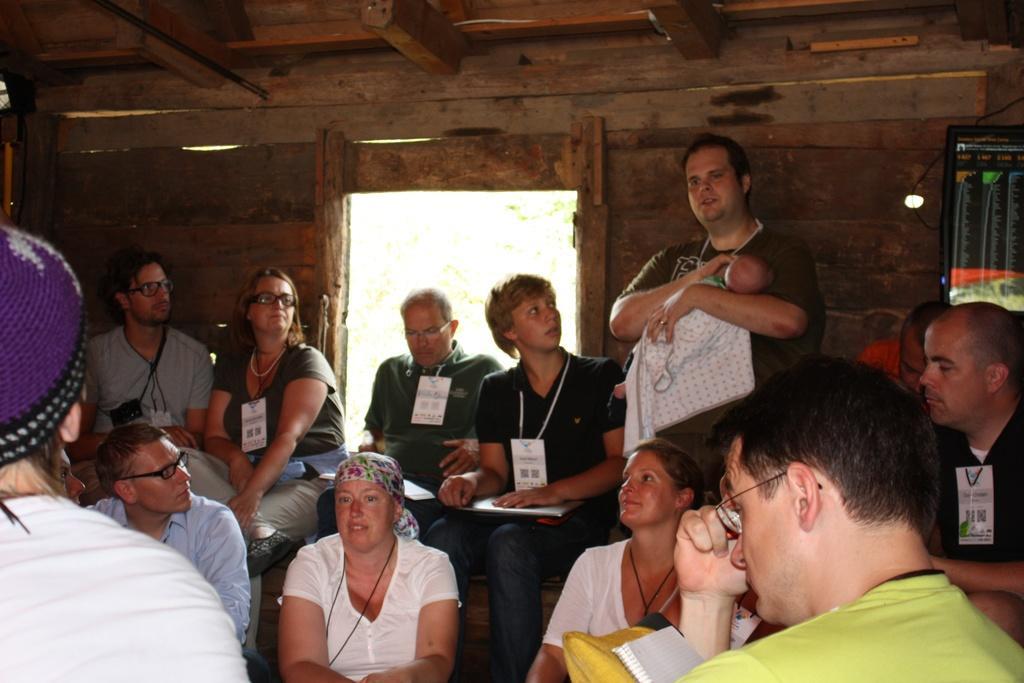Describe this image in one or two sentences. In this picture we can observe some people sitting in a wooden cabin. There are men and women in this picture. All of them were wearing white color tags in their necks. We can observe an entrance here. 